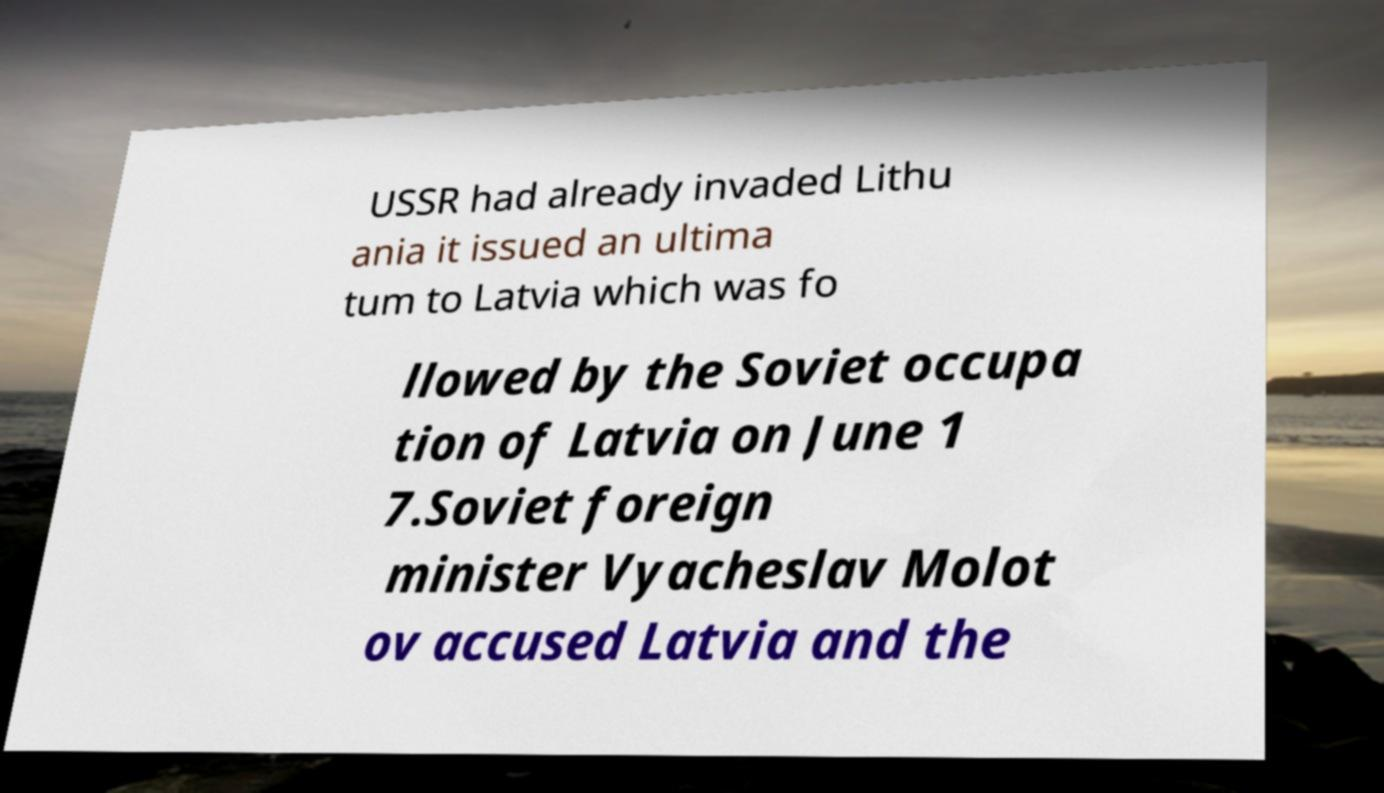Can you read and provide the text displayed in the image?This photo seems to have some interesting text. Can you extract and type it out for me? USSR had already invaded Lithu ania it issued an ultima tum to Latvia which was fo llowed by the Soviet occupa tion of Latvia on June 1 7.Soviet foreign minister Vyacheslav Molot ov accused Latvia and the 